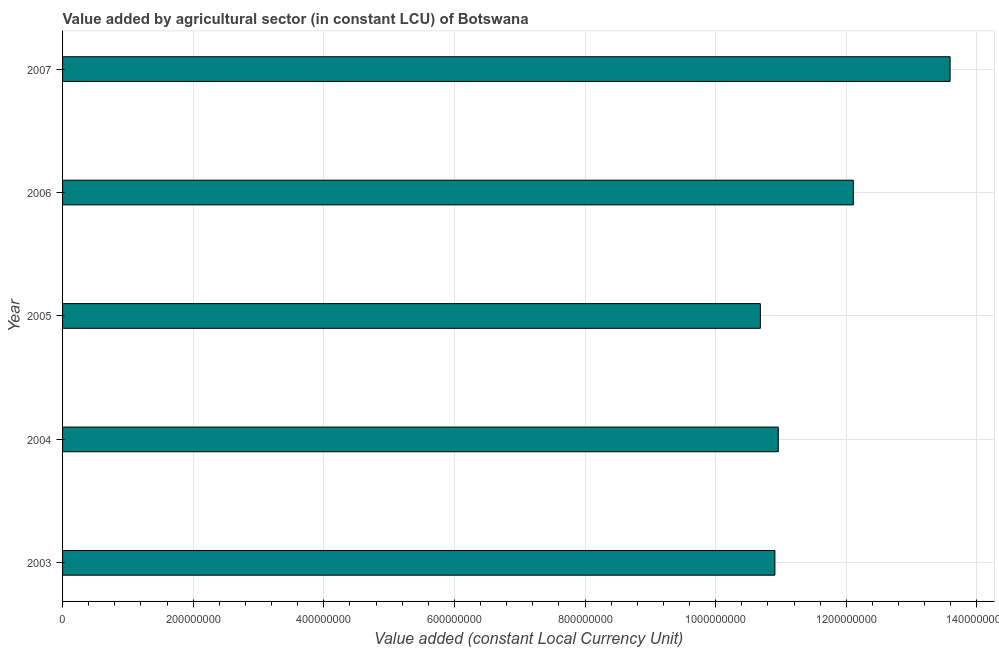Does the graph contain grids?
Your answer should be compact. Yes. What is the title of the graph?
Keep it short and to the point. Value added by agricultural sector (in constant LCU) of Botswana. What is the label or title of the X-axis?
Offer a terse response. Value added (constant Local Currency Unit). What is the label or title of the Y-axis?
Keep it short and to the point. Year. What is the value added by agriculture sector in 2005?
Keep it short and to the point. 1.07e+09. Across all years, what is the maximum value added by agriculture sector?
Keep it short and to the point. 1.36e+09. Across all years, what is the minimum value added by agriculture sector?
Your answer should be compact. 1.07e+09. In which year was the value added by agriculture sector maximum?
Give a very brief answer. 2007. In which year was the value added by agriculture sector minimum?
Your answer should be very brief. 2005. What is the sum of the value added by agriculture sector?
Give a very brief answer. 5.82e+09. What is the difference between the value added by agriculture sector in 2003 and 2005?
Provide a succinct answer. 2.23e+07. What is the average value added by agriculture sector per year?
Keep it short and to the point. 1.16e+09. What is the median value added by agriculture sector?
Make the answer very short. 1.10e+09. What is the ratio of the value added by agriculture sector in 2004 to that in 2006?
Offer a terse response. 0.91. What is the difference between the highest and the second highest value added by agriculture sector?
Offer a terse response. 1.48e+08. What is the difference between the highest and the lowest value added by agriculture sector?
Provide a short and direct response. 2.91e+08. Are all the bars in the graph horizontal?
Keep it short and to the point. Yes. How many years are there in the graph?
Make the answer very short. 5. What is the Value added (constant Local Currency Unit) in 2003?
Your answer should be compact. 1.09e+09. What is the Value added (constant Local Currency Unit) in 2004?
Provide a succinct answer. 1.10e+09. What is the Value added (constant Local Currency Unit) of 2005?
Your answer should be very brief. 1.07e+09. What is the Value added (constant Local Currency Unit) of 2006?
Provide a short and direct response. 1.21e+09. What is the Value added (constant Local Currency Unit) in 2007?
Your response must be concise. 1.36e+09. What is the difference between the Value added (constant Local Currency Unit) in 2003 and 2004?
Keep it short and to the point. -5.15e+06. What is the difference between the Value added (constant Local Currency Unit) in 2003 and 2005?
Offer a terse response. 2.23e+07. What is the difference between the Value added (constant Local Currency Unit) in 2003 and 2006?
Your response must be concise. -1.20e+08. What is the difference between the Value added (constant Local Currency Unit) in 2003 and 2007?
Give a very brief answer. -2.68e+08. What is the difference between the Value added (constant Local Currency Unit) in 2004 and 2005?
Your answer should be very brief. 2.74e+07. What is the difference between the Value added (constant Local Currency Unit) in 2004 and 2006?
Ensure brevity in your answer.  -1.15e+08. What is the difference between the Value added (constant Local Currency Unit) in 2004 and 2007?
Provide a succinct answer. -2.63e+08. What is the difference between the Value added (constant Local Currency Unit) in 2005 and 2006?
Ensure brevity in your answer.  -1.42e+08. What is the difference between the Value added (constant Local Currency Unit) in 2005 and 2007?
Offer a terse response. -2.91e+08. What is the difference between the Value added (constant Local Currency Unit) in 2006 and 2007?
Ensure brevity in your answer.  -1.48e+08. What is the ratio of the Value added (constant Local Currency Unit) in 2003 to that in 2004?
Provide a succinct answer. 0.99. What is the ratio of the Value added (constant Local Currency Unit) in 2003 to that in 2005?
Provide a succinct answer. 1.02. What is the ratio of the Value added (constant Local Currency Unit) in 2003 to that in 2006?
Give a very brief answer. 0.9. What is the ratio of the Value added (constant Local Currency Unit) in 2003 to that in 2007?
Make the answer very short. 0.8. What is the ratio of the Value added (constant Local Currency Unit) in 2004 to that in 2005?
Provide a short and direct response. 1.03. What is the ratio of the Value added (constant Local Currency Unit) in 2004 to that in 2006?
Provide a short and direct response. 0.91. What is the ratio of the Value added (constant Local Currency Unit) in 2004 to that in 2007?
Give a very brief answer. 0.81. What is the ratio of the Value added (constant Local Currency Unit) in 2005 to that in 2006?
Offer a terse response. 0.88. What is the ratio of the Value added (constant Local Currency Unit) in 2005 to that in 2007?
Provide a short and direct response. 0.79. What is the ratio of the Value added (constant Local Currency Unit) in 2006 to that in 2007?
Give a very brief answer. 0.89. 